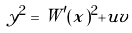<formula> <loc_0><loc_0><loc_500><loc_500>y ^ { 2 } = W ^ { \prime } ( x ) ^ { 2 } + u v</formula> 